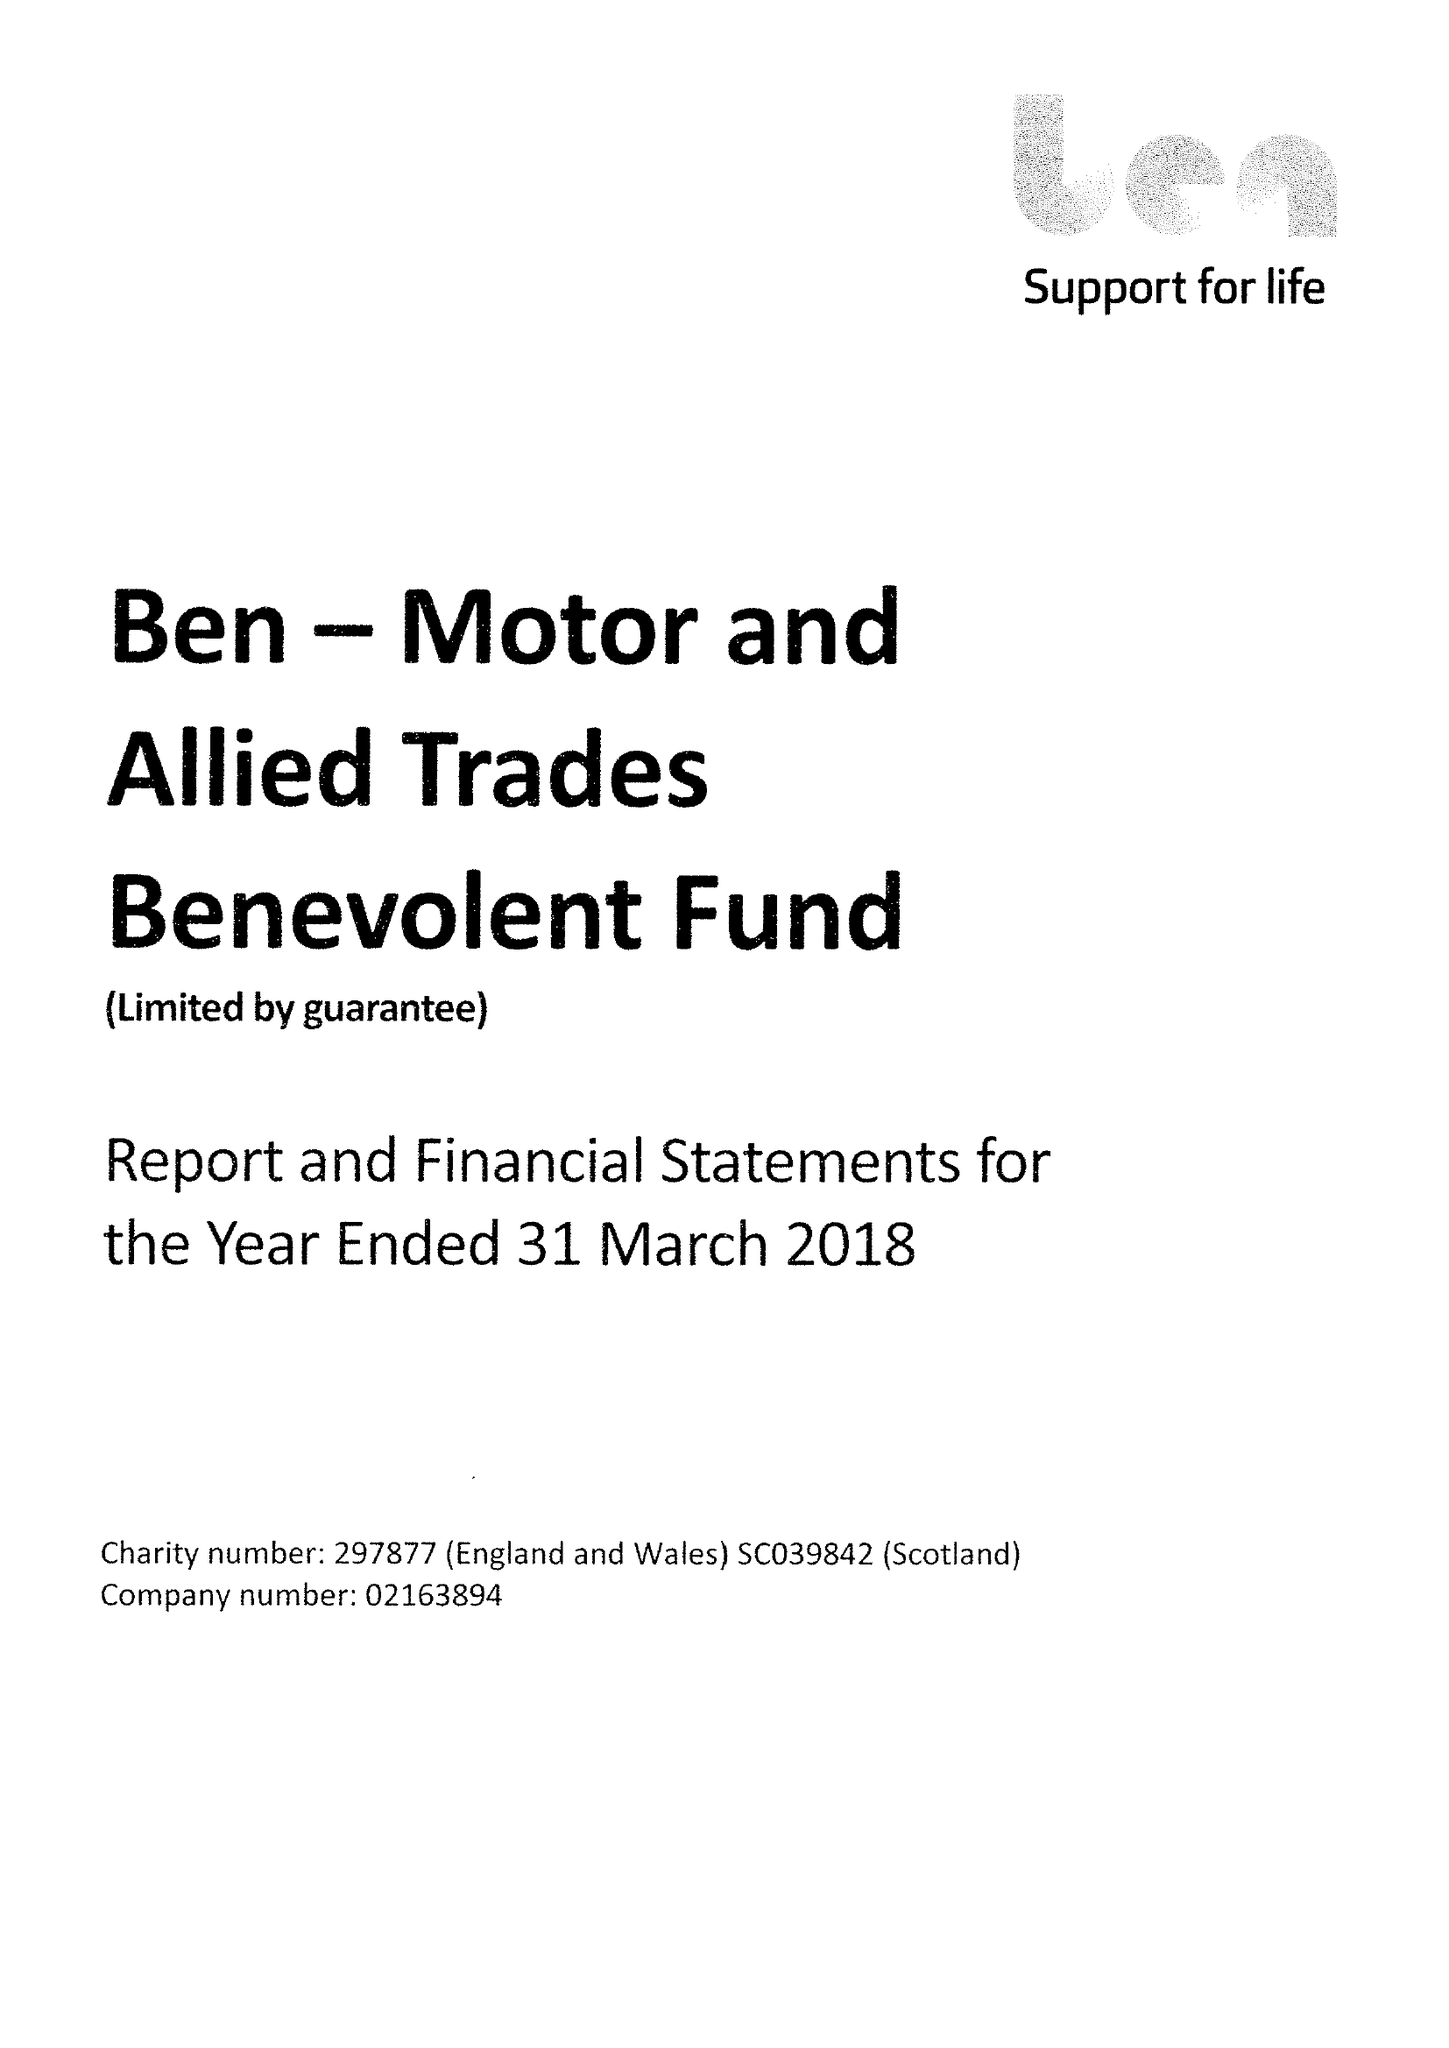What is the value for the spending_annually_in_british_pounds?
Answer the question using a single word or phrase. 25966000.00 